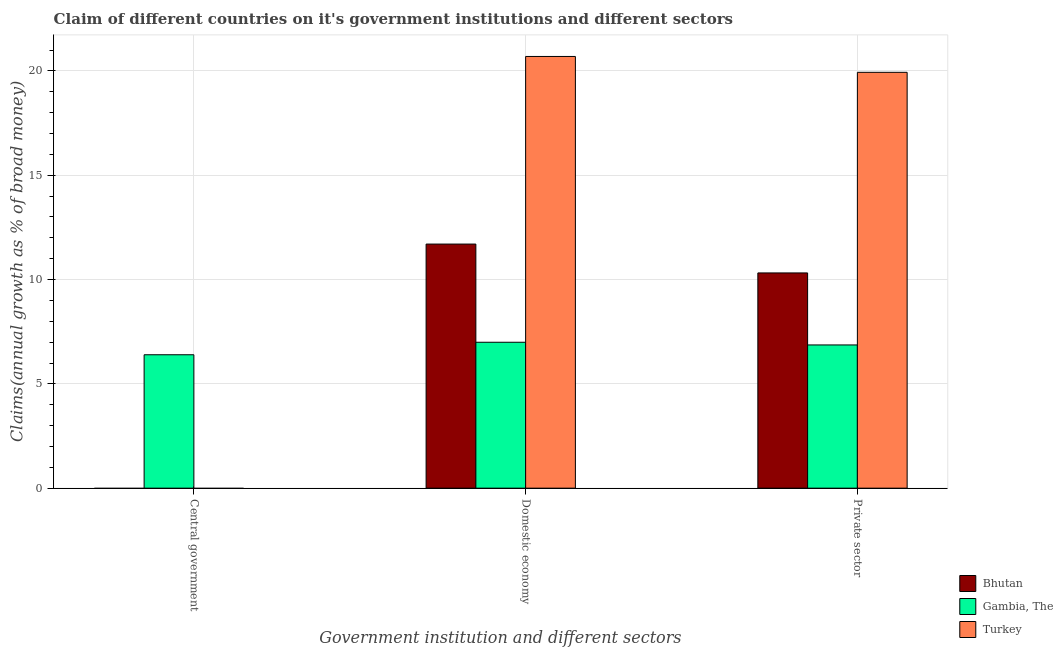How many different coloured bars are there?
Provide a succinct answer. 3. Are the number of bars per tick equal to the number of legend labels?
Give a very brief answer. No. Are the number of bars on each tick of the X-axis equal?
Your answer should be compact. No. How many bars are there on the 1st tick from the right?
Offer a very short reply. 3. What is the label of the 2nd group of bars from the left?
Make the answer very short. Domestic economy. What is the percentage of claim on the central government in Gambia, The?
Your answer should be very brief. 6.4. Across all countries, what is the maximum percentage of claim on the domestic economy?
Offer a terse response. 20.7. Across all countries, what is the minimum percentage of claim on the private sector?
Offer a terse response. 6.87. In which country was the percentage of claim on the domestic economy maximum?
Your answer should be very brief. Turkey. What is the total percentage of claim on the central government in the graph?
Your answer should be very brief. 6.4. What is the difference between the percentage of claim on the private sector in Bhutan and that in Turkey?
Provide a short and direct response. -9.62. What is the difference between the percentage of claim on the private sector in Turkey and the percentage of claim on the central government in Bhutan?
Your response must be concise. 19.94. What is the average percentage of claim on the private sector per country?
Ensure brevity in your answer.  12.37. What is the difference between the percentage of claim on the domestic economy and percentage of claim on the private sector in Bhutan?
Give a very brief answer. 1.38. What is the ratio of the percentage of claim on the private sector in Turkey to that in Gambia, The?
Your answer should be compact. 2.9. What is the difference between the highest and the second highest percentage of claim on the domestic economy?
Keep it short and to the point. 8.99. What is the difference between the highest and the lowest percentage of claim on the central government?
Offer a very short reply. 6.4. Are all the bars in the graph horizontal?
Offer a very short reply. No. What is the difference between two consecutive major ticks on the Y-axis?
Offer a very short reply. 5. Does the graph contain any zero values?
Provide a succinct answer. Yes. Does the graph contain grids?
Your answer should be very brief. Yes. How many legend labels are there?
Provide a short and direct response. 3. How are the legend labels stacked?
Your response must be concise. Vertical. What is the title of the graph?
Offer a terse response. Claim of different countries on it's government institutions and different sectors. Does "Bulgaria" appear as one of the legend labels in the graph?
Your response must be concise. No. What is the label or title of the X-axis?
Keep it short and to the point. Government institution and different sectors. What is the label or title of the Y-axis?
Your response must be concise. Claims(annual growth as % of broad money). What is the Claims(annual growth as % of broad money) of Gambia, The in Central government?
Offer a very short reply. 6.4. What is the Claims(annual growth as % of broad money) in Turkey in Central government?
Ensure brevity in your answer.  0. What is the Claims(annual growth as % of broad money) in Bhutan in Domestic economy?
Your answer should be compact. 11.7. What is the Claims(annual growth as % of broad money) in Gambia, The in Domestic economy?
Ensure brevity in your answer.  6.99. What is the Claims(annual growth as % of broad money) in Turkey in Domestic economy?
Make the answer very short. 20.7. What is the Claims(annual growth as % of broad money) of Bhutan in Private sector?
Provide a short and direct response. 10.32. What is the Claims(annual growth as % of broad money) of Gambia, The in Private sector?
Your answer should be very brief. 6.87. What is the Claims(annual growth as % of broad money) in Turkey in Private sector?
Your answer should be very brief. 19.94. Across all Government institution and different sectors, what is the maximum Claims(annual growth as % of broad money) in Bhutan?
Give a very brief answer. 11.7. Across all Government institution and different sectors, what is the maximum Claims(annual growth as % of broad money) of Gambia, The?
Offer a very short reply. 6.99. Across all Government institution and different sectors, what is the maximum Claims(annual growth as % of broad money) of Turkey?
Ensure brevity in your answer.  20.7. Across all Government institution and different sectors, what is the minimum Claims(annual growth as % of broad money) of Bhutan?
Provide a succinct answer. 0. Across all Government institution and different sectors, what is the minimum Claims(annual growth as % of broad money) of Gambia, The?
Provide a short and direct response. 6.4. What is the total Claims(annual growth as % of broad money) of Bhutan in the graph?
Offer a very short reply. 22.02. What is the total Claims(annual growth as % of broad money) of Gambia, The in the graph?
Your answer should be compact. 20.26. What is the total Claims(annual growth as % of broad money) of Turkey in the graph?
Your answer should be compact. 40.63. What is the difference between the Claims(annual growth as % of broad money) in Gambia, The in Central government and that in Domestic economy?
Offer a terse response. -0.6. What is the difference between the Claims(annual growth as % of broad money) of Gambia, The in Central government and that in Private sector?
Provide a short and direct response. -0.47. What is the difference between the Claims(annual growth as % of broad money) in Bhutan in Domestic economy and that in Private sector?
Your response must be concise. 1.38. What is the difference between the Claims(annual growth as % of broad money) in Gambia, The in Domestic economy and that in Private sector?
Ensure brevity in your answer.  0.13. What is the difference between the Claims(annual growth as % of broad money) of Turkey in Domestic economy and that in Private sector?
Offer a very short reply. 0.76. What is the difference between the Claims(annual growth as % of broad money) of Gambia, The in Central government and the Claims(annual growth as % of broad money) of Turkey in Domestic economy?
Your answer should be compact. -14.3. What is the difference between the Claims(annual growth as % of broad money) of Gambia, The in Central government and the Claims(annual growth as % of broad money) of Turkey in Private sector?
Your answer should be compact. -13.54. What is the difference between the Claims(annual growth as % of broad money) of Bhutan in Domestic economy and the Claims(annual growth as % of broad money) of Gambia, The in Private sector?
Offer a very short reply. 4.84. What is the difference between the Claims(annual growth as % of broad money) of Bhutan in Domestic economy and the Claims(annual growth as % of broad money) of Turkey in Private sector?
Offer a terse response. -8.23. What is the difference between the Claims(annual growth as % of broad money) of Gambia, The in Domestic economy and the Claims(annual growth as % of broad money) of Turkey in Private sector?
Keep it short and to the point. -12.94. What is the average Claims(annual growth as % of broad money) of Bhutan per Government institution and different sectors?
Your answer should be very brief. 7.34. What is the average Claims(annual growth as % of broad money) of Gambia, The per Government institution and different sectors?
Your response must be concise. 6.75. What is the average Claims(annual growth as % of broad money) of Turkey per Government institution and different sectors?
Your answer should be compact. 13.54. What is the difference between the Claims(annual growth as % of broad money) of Bhutan and Claims(annual growth as % of broad money) of Gambia, The in Domestic economy?
Provide a short and direct response. 4.71. What is the difference between the Claims(annual growth as % of broad money) of Bhutan and Claims(annual growth as % of broad money) of Turkey in Domestic economy?
Ensure brevity in your answer.  -8.99. What is the difference between the Claims(annual growth as % of broad money) of Gambia, The and Claims(annual growth as % of broad money) of Turkey in Domestic economy?
Make the answer very short. -13.7. What is the difference between the Claims(annual growth as % of broad money) of Bhutan and Claims(annual growth as % of broad money) of Gambia, The in Private sector?
Provide a succinct answer. 3.45. What is the difference between the Claims(annual growth as % of broad money) in Bhutan and Claims(annual growth as % of broad money) in Turkey in Private sector?
Your response must be concise. -9.62. What is the difference between the Claims(annual growth as % of broad money) of Gambia, The and Claims(annual growth as % of broad money) of Turkey in Private sector?
Ensure brevity in your answer.  -13.07. What is the ratio of the Claims(annual growth as % of broad money) of Gambia, The in Central government to that in Domestic economy?
Your response must be concise. 0.91. What is the ratio of the Claims(annual growth as % of broad money) in Gambia, The in Central government to that in Private sector?
Your answer should be very brief. 0.93. What is the ratio of the Claims(annual growth as % of broad money) of Bhutan in Domestic economy to that in Private sector?
Provide a short and direct response. 1.13. What is the ratio of the Claims(annual growth as % of broad money) in Gambia, The in Domestic economy to that in Private sector?
Keep it short and to the point. 1.02. What is the ratio of the Claims(annual growth as % of broad money) in Turkey in Domestic economy to that in Private sector?
Offer a very short reply. 1.04. What is the difference between the highest and the second highest Claims(annual growth as % of broad money) of Gambia, The?
Offer a very short reply. 0.13. What is the difference between the highest and the lowest Claims(annual growth as % of broad money) in Bhutan?
Your answer should be very brief. 11.7. What is the difference between the highest and the lowest Claims(annual growth as % of broad money) of Gambia, The?
Your response must be concise. 0.6. What is the difference between the highest and the lowest Claims(annual growth as % of broad money) of Turkey?
Provide a short and direct response. 20.7. 